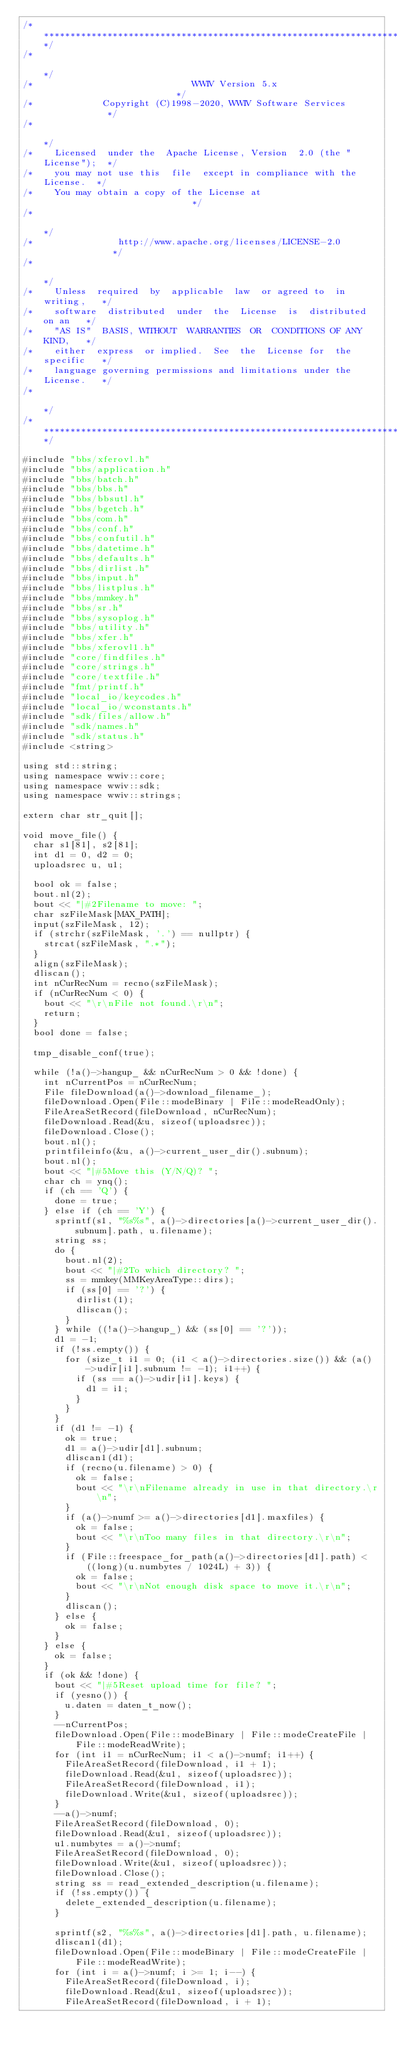<code> <loc_0><loc_0><loc_500><loc_500><_C++_>/**************************************************************************/
/*                                                                        */
/*                              WWIV Version 5.x                          */
/*             Copyright (C)1998-2020, WWIV Software Services             */
/*                                                                        */
/*    Licensed  under the  Apache License, Version  2.0 (the "License");  */
/*    you may not use this  file  except in compliance with the License.  */
/*    You may obtain a copy of the License at                             */
/*                                                                        */
/*                http://www.apache.org/licenses/LICENSE-2.0              */
/*                                                                        */
/*    Unless  required  by  applicable  law  or agreed to  in  writing,   */
/*    software  distributed  under  the  License  is  distributed on an   */
/*    "AS IS"  BASIS, WITHOUT  WARRANTIES  OR  CONDITIONS OF ANY  KIND,   */
/*    either  express  or implied.  See  the  License for  the specific   */
/*    language governing permissions and limitations under the License.   */
/*                                                                        */
/**************************************************************************/

#include "bbs/xferovl.h"
#include "bbs/application.h"
#include "bbs/batch.h"
#include "bbs/bbs.h"
#include "bbs/bbsutl.h"
#include "bbs/bgetch.h"
#include "bbs/com.h"
#include "bbs/conf.h"
#include "bbs/confutil.h"
#include "bbs/datetime.h"
#include "bbs/defaults.h"
#include "bbs/dirlist.h"
#include "bbs/input.h"
#include "bbs/listplus.h"
#include "bbs/mmkey.h"
#include "bbs/sr.h"
#include "bbs/sysoplog.h"
#include "bbs/utility.h"
#include "bbs/xfer.h"
#include "bbs/xferovl1.h"
#include "core/findfiles.h"
#include "core/strings.h"
#include "core/textfile.h"
#include "fmt/printf.h"
#include "local_io/keycodes.h"
#include "local_io/wconstants.h"
#include "sdk/files/allow.h"
#include "sdk/names.h"
#include "sdk/status.h"
#include <string>

using std::string;
using namespace wwiv::core;
using namespace wwiv::sdk;
using namespace wwiv::strings;

extern char str_quit[];

void move_file() {
  char s1[81], s2[81];
  int d1 = 0, d2 = 0;
  uploadsrec u, u1;

  bool ok = false;
  bout.nl(2);
  bout << "|#2Filename to move: ";
  char szFileMask[MAX_PATH];
  input(szFileMask, 12);
  if (strchr(szFileMask, '.') == nullptr) {
    strcat(szFileMask, ".*");
  }
  align(szFileMask);
  dliscan();
  int nCurRecNum = recno(szFileMask);
  if (nCurRecNum < 0) {
    bout << "\r\nFile not found.\r\n";
    return;
  }
  bool done = false;

  tmp_disable_conf(true);

  while (!a()->hangup_ && nCurRecNum > 0 && !done) {
    int nCurrentPos = nCurRecNum;
    File fileDownload(a()->download_filename_);
    fileDownload.Open(File::modeBinary | File::modeReadOnly);
    FileAreaSetRecord(fileDownload, nCurRecNum);
    fileDownload.Read(&u, sizeof(uploadsrec));
    fileDownload.Close();
    bout.nl();
    printfileinfo(&u, a()->current_user_dir().subnum);
    bout.nl();
    bout << "|#5Move this (Y/N/Q)? ";
    char ch = ynq();
    if (ch == 'Q') {
      done = true;
    } else if (ch == 'Y') {
      sprintf(s1, "%s%s", a()->directories[a()->current_user_dir().subnum].path, u.filename);
      string ss;
      do {
        bout.nl(2);
        bout << "|#2To which directory? ";
        ss = mmkey(MMKeyAreaType::dirs);
        if (ss[0] == '?') {
          dirlist(1);
          dliscan();
        }
      } while ((!a()->hangup_) && (ss[0] == '?'));
      d1 = -1;
      if (!ss.empty()) {
        for (size_t i1 = 0; (i1 < a()->directories.size()) && (a()->udir[i1].subnum != -1); i1++) {
          if (ss == a()->udir[i1].keys) {
            d1 = i1;
          }
        }
      }
      if (d1 != -1) {
        ok = true;
        d1 = a()->udir[d1].subnum;
        dliscan1(d1);
        if (recno(u.filename) > 0) {
          ok = false;
          bout << "\r\nFilename already in use in that directory.\r\n";
        }
        if (a()->numf >= a()->directories[d1].maxfiles) {
          ok = false;
          bout << "\r\nToo many files in that directory.\r\n";
        }
        if (File::freespace_for_path(a()->directories[d1].path) <
            ((long)(u.numbytes / 1024L) + 3)) {
          ok = false;
          bout << "\r\nNot enough disk space to move it.\r\n";
        }
        dliscan();
      } else {
        ok = false;
      }
    } else {
      ok = false;
    }
    if (ok && !done) {
      bout << "|#5Reset upload time for file? ";
      if (yesno()) {
        u.daten = daten_t_now();
      }
      --nCurrentPos;
      fileDownload.Open(File::modeBinary | File::modeCreateFile | File::modeReadWrite);
      for (int i1 = nCurRecNum; i1 < a()->numf; i1++) {
        FileAreaSetRecord(fileDownload, i1 + 1);
        fileDownload.Read(&u1, sizeof(uploadsrec));
        FileAreaSetRecord(fileDownload, i1);
        fileDownload.Write(&u1, sizeof(uploadsrec));
      }
      --a()->numf;
      FileAreaSetRecord(fileDownload, 0);
      fileDownload.Read(&u1, sizeof(uploadsrec));
      u1.numbytes = a()->numf;
      FileAreaSetRecord(fileDownload, 0);
      fileDownload.Write(&u1, sizeof(uploadsrec));
      fileDownload.Close();
      string ss = read_extended_description(u.filename);
      if (!ss.empty()) {
        delete_extended_description(u.filename);
      }

      sprintf(s2, "%s%s", a()->directories[d1].path, u.filename);
      dliscan1(d1);
      fileDownload.Open(File::modeBinary | File::modeCreateFile | File::modeReadWrite);
      for (int i = a()->numf; i >= 1; i--) {
        FileAreaSetRecord(fileDownload, i);
        fileDownload.Read(&u1, sizeof(uploadsrec));
        FileAreaSetRecord(fileDownload, i + 1);</code> 